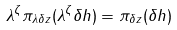<formula> <loc_0><loc_0><loc_500><loc_500>\lambda ^ { \zeta } \pi _ { \lambda \delta z } ( \lambda ^ { \zeta } \delta h ) = \pi _ { \delta z } ( \delta h )</formula> 